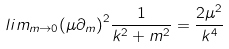Convert formula to latex. <formula><loc_0><loc_0><loc_500><loc_500>l i m _ { m \rightarrow 0 } { ( \mu \partial _ { m } ) } ^ { 2 } \frac { 1 } { k ^ { 2 } + m ^ { 2 } } = \frac { 2 \mu ^ { 2 } } { k ^ { 4 } }</formula> 